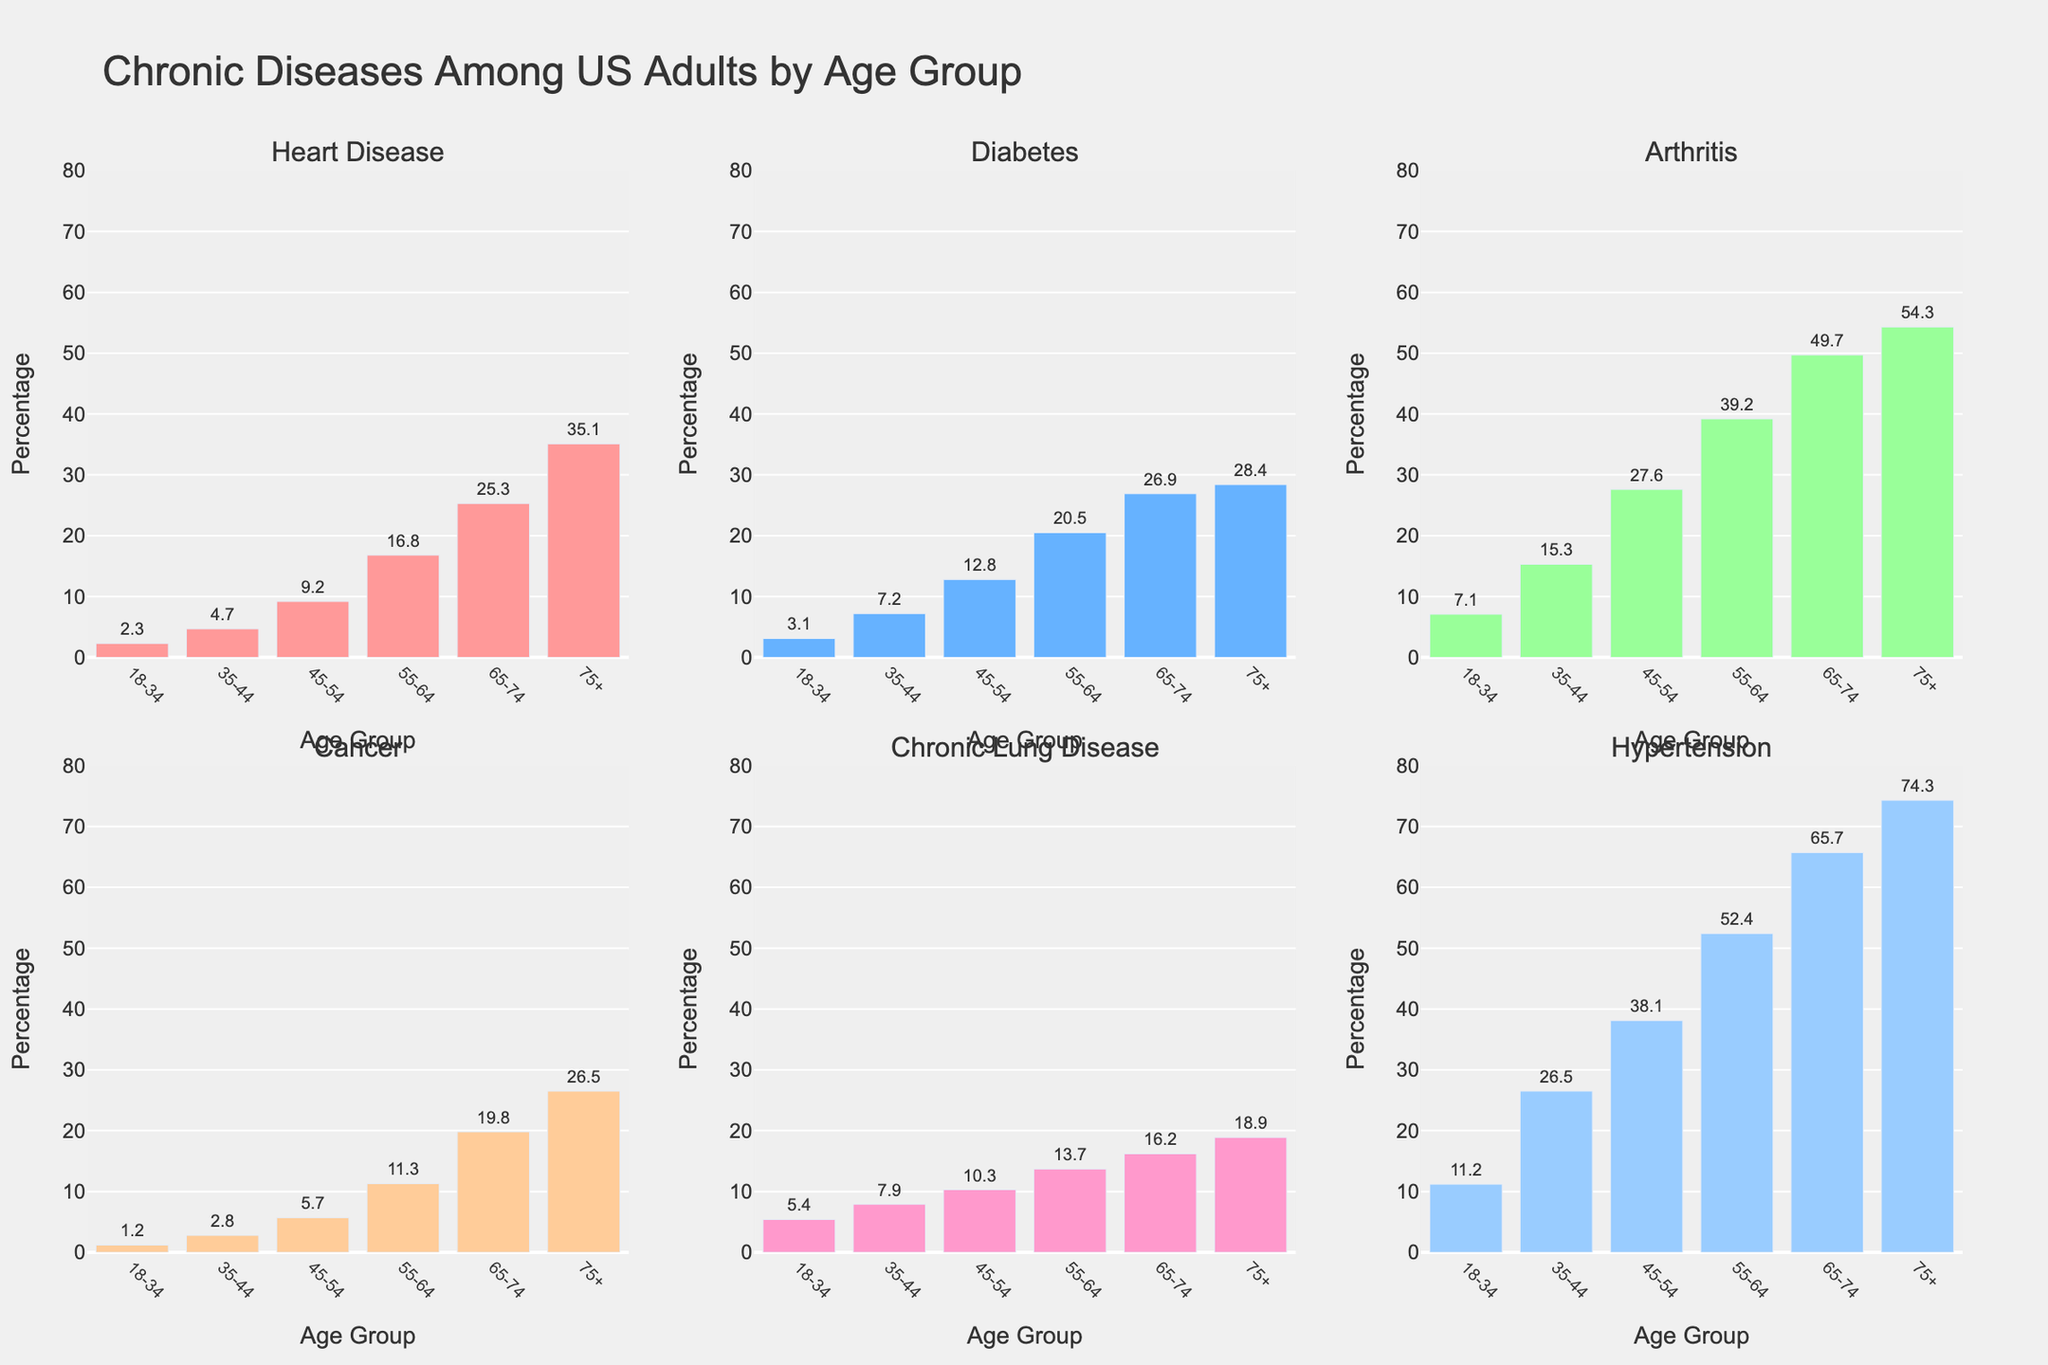What’s the total percentage of adults aged 75+ who have both Diabetes and Hypertension? For the age group 75+, the percentage for Diabetes is 28.4%, and for Hypertension, it is 74.3%. Adding these together, 28.4 + 74.3 = 102.7%
Answer: 102.7% Which age group has the highest percentage of adults with Heart Disease? Looking at the plot, the age group 75+ has the tallest bar in the Heart Disease panel, indicating the highest percentage at 35.1%
Answer: Age 75+ Compare the levels of Arthritis between age groups 35-44 and 55-64. How much higher is it in 55-64 compared to 35-44? The percentage of Arthritis in the 35-44 age group is 15.3%, and in the 55-64 age group, it is 39.2%. The difference is 39.2 - 15.3 = 23.9%
Answer: 23.9% In which age group does Chronic Lung Disease have the smallest percentage? The shortest bar in the Chronic Lung Disease panel represents the 18-34 age group with a percentage of 5.4%
Answer: Age 18-34 Calculate the average percentage of Cancer across all age groups. The percentages for Cancer are 1.2, 2.8, 5.7, 11.3, 19.8, and 26.5 respectively for the age groups. Summing these gives 1.2 + 2.8 + 5.7 + 11.3 + 19.8 + 26.5 = 67.3. Dividing by the number of age groups (6), the average is 67.3 / 6 ≈ 11.2%
Answer: 11.2% Is Arthritis more common in the age group 65-74 or Chronic Lung Disease in the same age group? The bar for Arthritis in the age group 65-74 is taller than the bar for Chronic Lung Disease in the same group. The percentage for Arthritis is 49.7%, and for Chronic Lung Disease, it is 16.2%
Answer: Arthritis How does the percentage of Diabetes in the 45-54 age group compare to that in the 18-34 age group? The percentage of Diabetes in the 45-54 age group is 12.8% compared to 3.1% in the 18-34 age group. To find how much higher it is, calculate 12.8 - 3.1 = 9.7%
Answer: 9.7% In which age group does Hypertension have the second highest percentage? The second tallest bar in the Hypertension panel corresponds to the age group 65-74 with a percentage of 65.7%
Answer: Age 65-74 